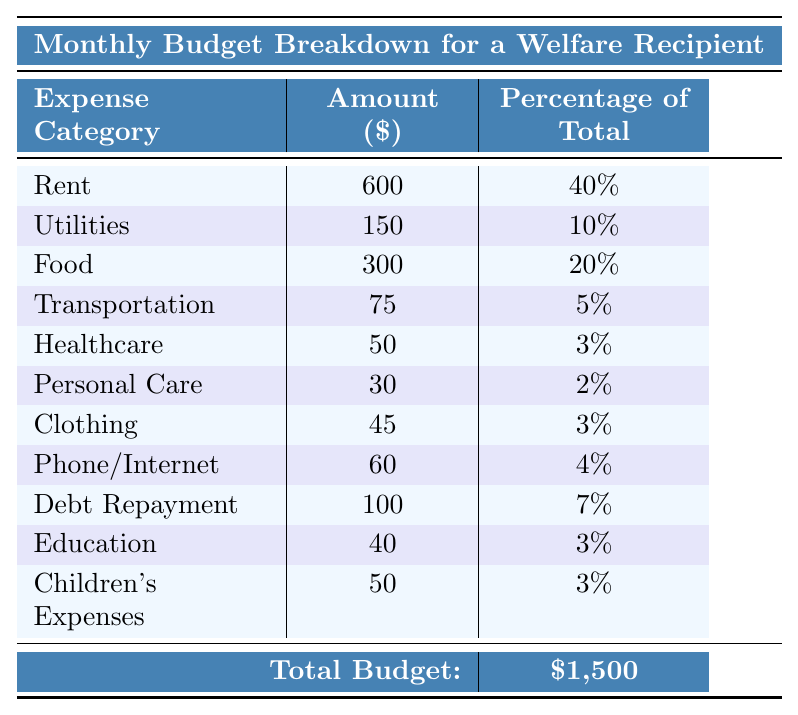What is the largest expense category? Looking at the table, the "Rent" category has the highest amount listed, which is $600.
Answer: Rent How much do food expenses account for in percentage? The table shows that food expenses make up 20% of the total budget.
Answer: 20% What is the total amount spent on utilities and transportation? Adding the amounts for utilities ($150) and transportation ($75) gives $150 + $75 = $225.
Answer: $225 What percentage of the total budget is spent on healthcare? The table directly states that healthcare expenses are 3% of the total budget.
Answer: 3% Is transportation the lowest expense category? By looking at the amounts listed, transportation ($75) is indeed less than healthcare ($50) and personal care ($30), making it not the lowest.
Answer: No How much is spent on clothing compared to children's expenses? Clothing expenses are $45 and children's expenses are $50. Since $50 is greater than $45, we conclude that spending on children's expenses is higher.
Answer: Children's expenses are higher If the budget was increased by $500, what would be the new total budget? The original total budget is $1,500. Adding $500 gives $1,500 + $500 = $2,000 as the new budget.
Answer: $2,000 What is the combined percentage of rent and food in the total budget? Rent is 40% and food is 20%. Adding these percentages together gives 40% + 20% = 60%.
Answer: 60% Which expense category has a percentage closest to the average percentage of all categories? The total percentages amount to 100%, and there are 10 categories, so the average is 10%. The category closest to this is "Healthcare" at 3%.
Answer: Healthcare How much more is spent on debt repayment than personal care? Debt repayment is $100 while personal care is $30. The difference is $100 - $30 = $70.
Answer: $70 What is the total amount allocated for education and clothing together? Education expenses are $40 and clothing expenses are $45. Summing these together gives $40 + $45 = $85.
Answer: $85 